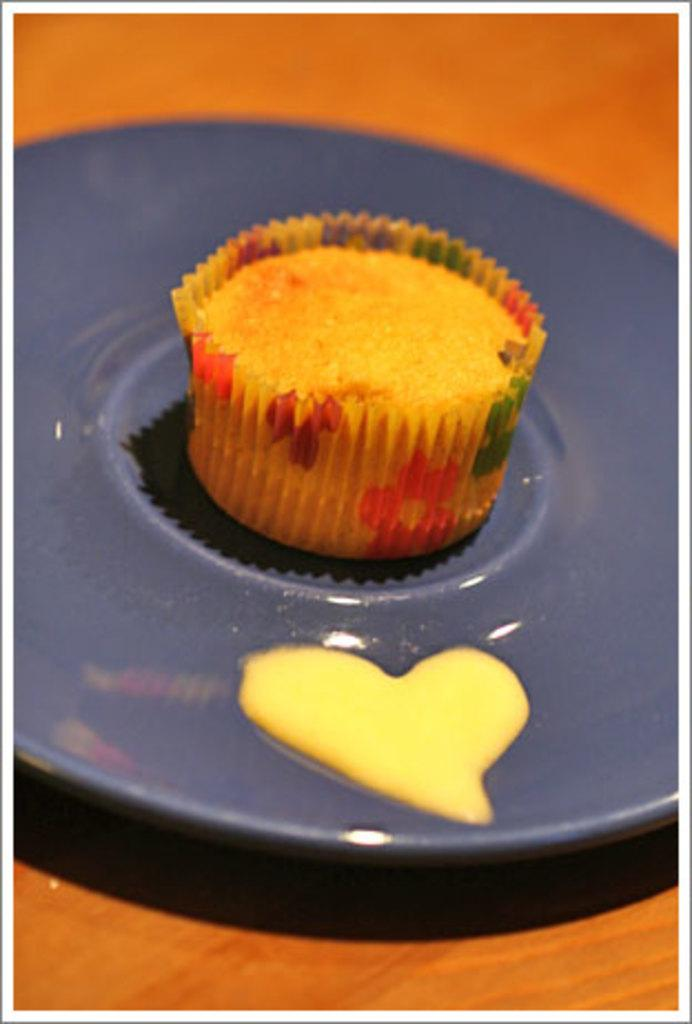What is the main piece of furniture in the image? There is a table in the image. What is placed on the table? There is a plate on the table. What is on the plate? The plate contains a cupcake. How many secretaries are present in the image? There are no secretaries present in the image. What is the starting point of the cupcake in the image? The cupcake is already on the plate, so there is no starting point in the image. 